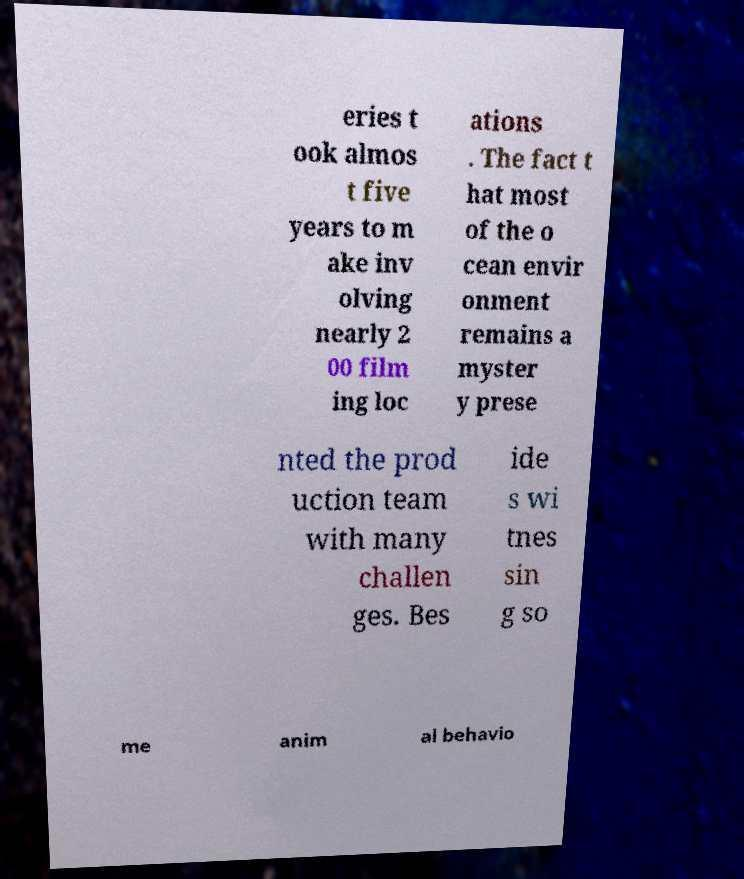Please read and relay the text visible in this image. What does it say? eries t ook almos t five years to m ake inv olving nearly 2 00 film ing loc ations . The fact t hat most of the o cean envir onment remains a myster y prese nted the prod uction team with many challen ges. Bes ide s wi tnes sin g so me anim al behavio 